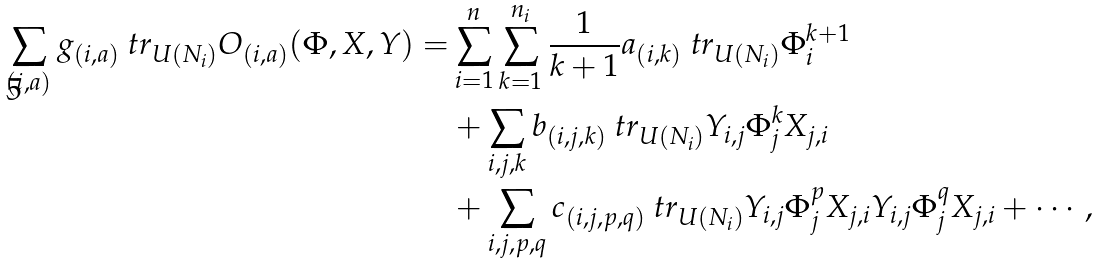Convert formula to latex. <formula><loc_0><loc_0><loc_500><loc_500>\sum _ { ( i , a ) } g _ { ( i , a ) } \ t r _ { U ( N _ { i } ) } O _ { ( i , a ) } ( \Phi , X , Y ) = & \sum _ { i = 1 } ^ { n } \sum _ { k = 1 } ^ { n _ { i } } \frac { 1 } { k + 1 } a _ { ( i , k ) } \ t r _ { U ( N _ { i } ) } \Phi _ { i } ^ { k + 1 } \\ & + \sum _ { i , j , k } b _ { ( i , j , k ) } \ t r _ { U ( N _ { i } ) } Y _ { i , j } \Phi ^ { k } _ { j } X _ { j , i } \\ & + \sum _ { i , j , p , q } c _ { ( i , j , p , q ) } \ t r _ { U ( N _ { i } ) } Y _ { i , j } \Phi ^ { p } _ { j } X _ { j , i } Y _ { i , j } \Phi ^ { q } _ { j } X _ { j , i } + \cdots ,</formula> 